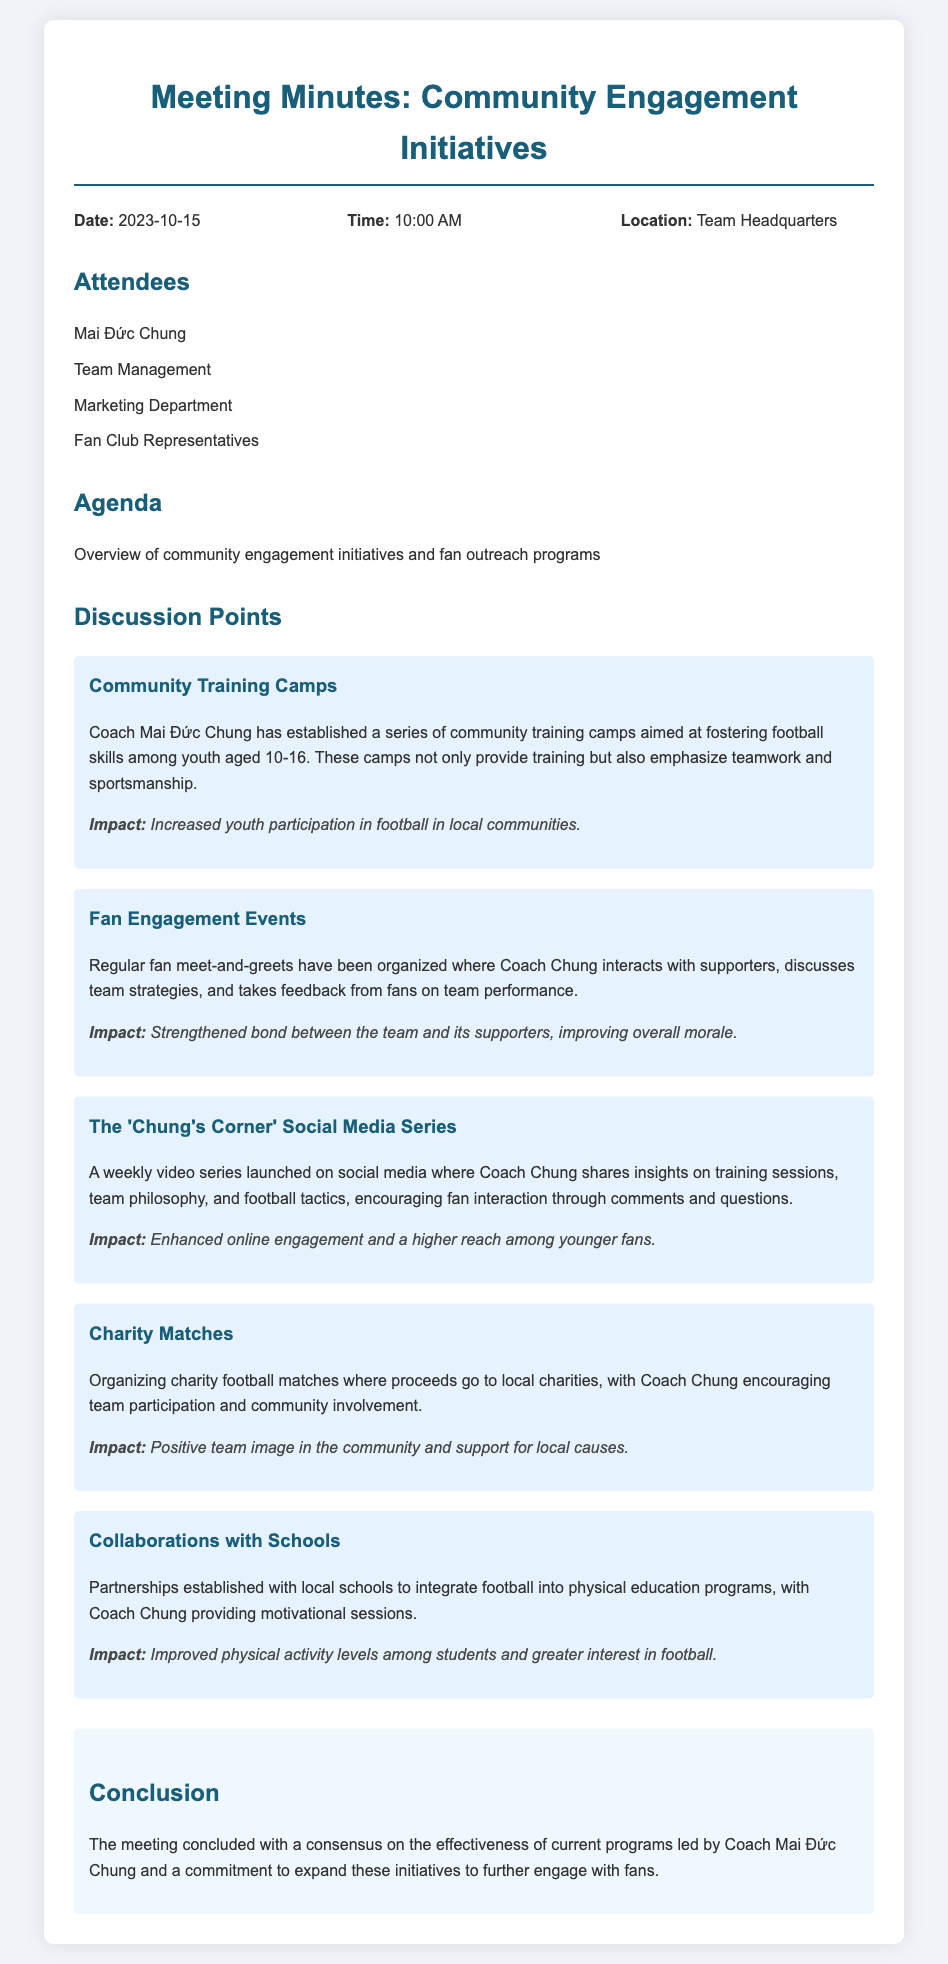What is the date of the meeting? The date is mentioned in the header information section of the document.
Answer: 2023-10-15 Who hosted the community engagement initiatives meeting? The meeting's host is indicated in the attendee list, where Coach Mai Đức Chung's name is present.
Answer: Mai Đức Chung What is one impact of the Community Training Camps? The impact is stated directly after the initiative description and relates to youth involvement in football.
Answer: Increased youth participation in football in local communities What is the purpose of the 'Chung's Corner' Social Media Series? The purpose of the series is described in the initiative section, focusing on sharing insights and encouraging interaction.
Answer: Encourage fan interaction How many initiatives are discussed in the meeting? The number of initiatives can be counted from the discussion points section, which lists several community engagement initiatives.
Answer: Five What is the main focus of the Charity Matches? The main focus is contained within the description of the initiative, specifically addressing community involvement.
Answer: Support for local charities What type of partnership does Coach Mai Đức Chung have with local schools? The partnership type is specified in the initiatives section, indicating an integration into educational programs.
Answer: Integrate football into physical education programs What time did the meeting start? The time is noted in the header information of the document.
Answer: 10:00 AM 